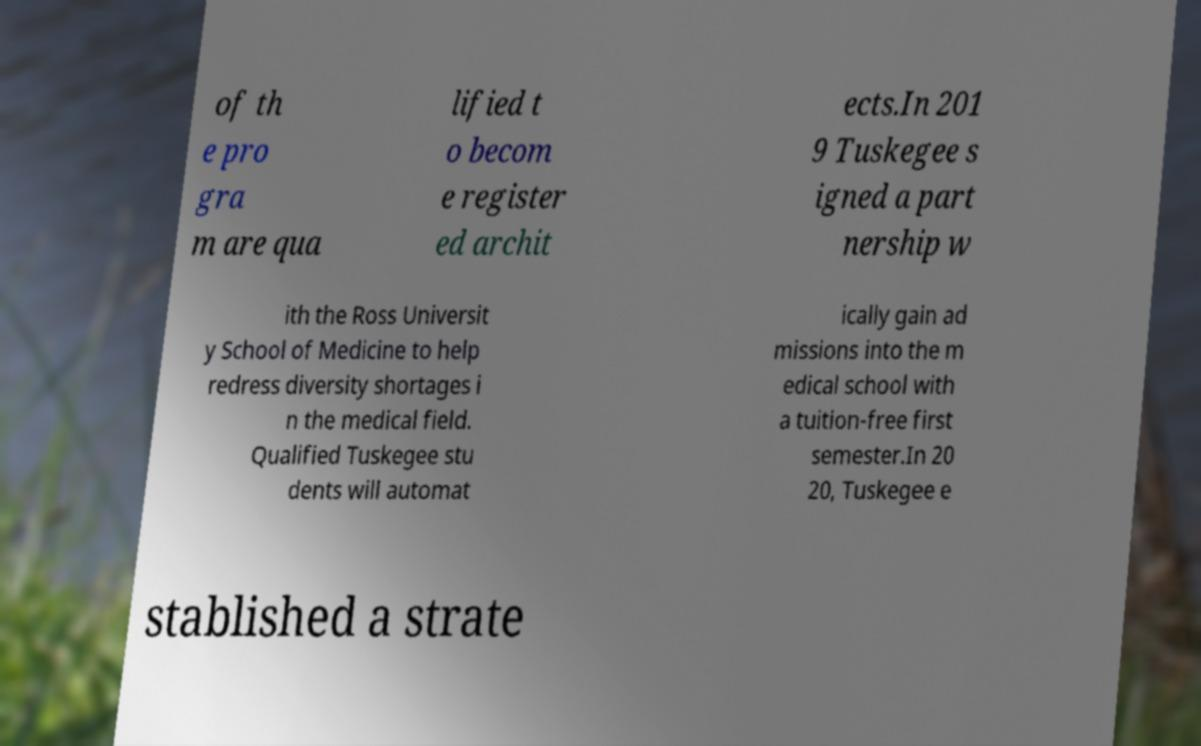What messages or text are displayed in this image? I need them in a readable, typed format. of th e pro gra m are qua lified t o becom e register ed archit ects.In 201 9 Tuskegee s igned a part nership w ith the Ross Universit y School of Medicine to help redress diversity shortages i n the medical field. Qualified Tuskegee stu dents will automat ically gain ad missions into the m edical school with a tuition-free first semester.In 20 20, Tuskegee e stablished a strate 